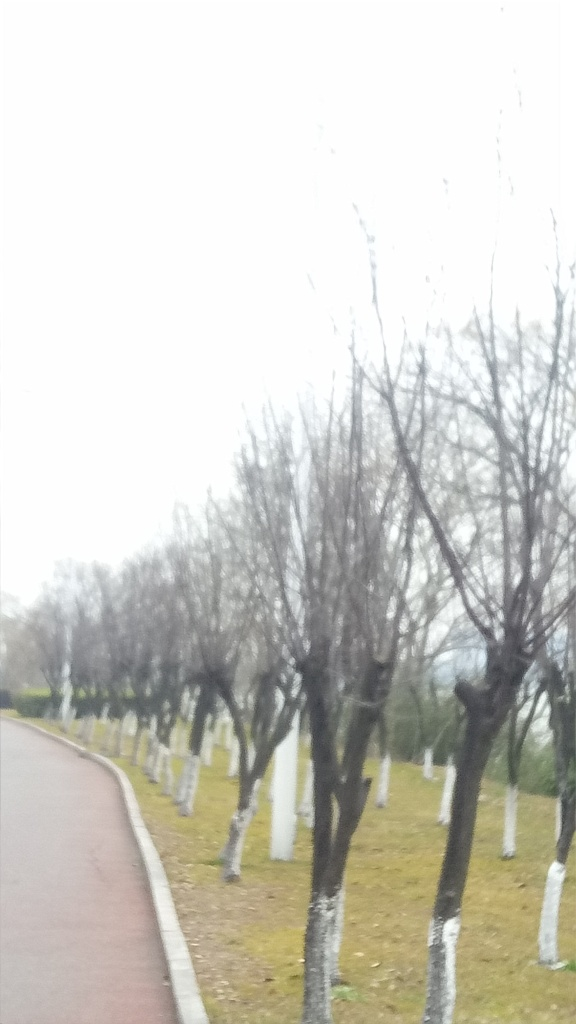What time of year does this photo seem to be taken during? Given the lack of leaves on the trees and the grass's dormant, yellowish hue, the photo seems to have been taken in late fall or winter, which are times when many trees shed their leaves and cooler temperatures may hinder the growth of lush, green grass. 